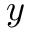<formula> <loc_0><loc_0><loc_500><loc_500>y</formula> 